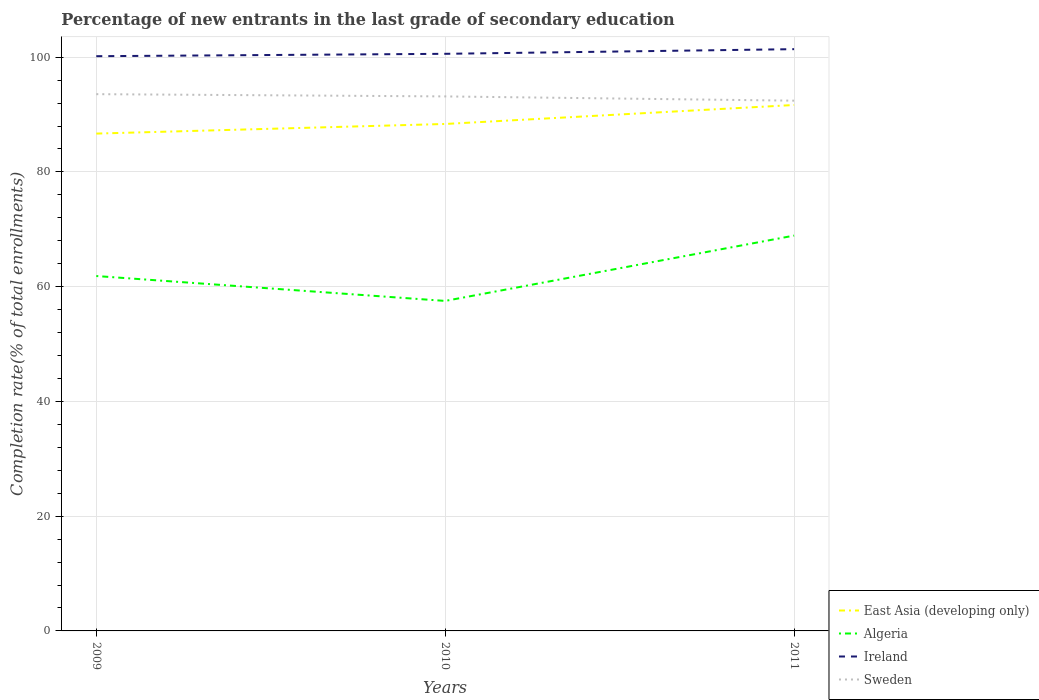How many different coloured lines are there?
Offer a very short reply. 4. Does the line corresponding to Sweden intersect with the line corresponding to Ireland?
Provide a succinct answer. No. Across all years, what is the maximum percentage of new entrants in Ireland?
Your answer should be compact. 100.17. In which year was the percentage of new entrants in Sweden maximum?
Your answer should be very brief. 2011. What is the total percentage of new entrants in Algeria in the graph?
Offer a very short reply. -7.05. What is the difference between the highest and the second highest percentage of new entrants in Sweden?
Your answer should be compact. 1.14. What is the difference between the highest and the lowest percentage of new entrants in East Asia (developing only)?
Offer a terse response. 1. Is the percentage of new entrants in Ireland strictly greater than the percentage of new entrants in Algeria over the years?
Your response must be concise. No. How many lines are there?
Your response must be concise. 4. What is the difference between two consecutive major ticks on the Y-axis?
Offer a terse response. 20. Does the graph contain any zero values?
Your answer should be compact. No. What is the title of the graph?
Your answer should be compact. Percentage of new entrants in the last grade of secondary education. What is the label or title of the Y-axis?
Provide a succinct answer. Completion rate(% of total enrollments). What is the Completion rate(% of total enrollments) in East Asia (developing only) in 2009?
Your answer should be very brief. 86.68. What is the Completion rate(% of total enrollments) in Algeria in 2009?
Provide a short and direct response. 61.86. What is the Completion rate(% of total enrollments) in Ireland in 2009?
Offer a very short reply. 100.17. What is the Completion rate(% of total enrollments) in Sweden in 2009?
Your answer should be compact. 93.56. What is the Completion rate(% of total enrollments) in East Asia (developing only) in 2010?
Ensure brevity in your answer.  88.36. What is the Completion rate(% of total enrollments) in Algeria in 2010?
Offer a terse response. 57.52. What is the Completion rate(% of total enrollments) in Ireland in 2010?
Make the answer very short. 100.59. What is the Completion rate(% of total enrollments) of Sweden in 2010?
Offer a very short reply. 93.16. What is the Completion rate(% of total enrollments) in East Asia (developing only) in 2011?
Offer a terse response. 91.67. What is the Completion rate(% of total enrollments) of Algeria in 2011?
Provide a short and direct response. 68.9. What is the Completion rate(% of total enrollments) in Ireland in 2011?
Your answer should be compact. 101.4. What is the Completion rate(% of total enrollments) of Sweden in 2011?
Provide a succinct answer. 92.42. Across all years, what is the maximum Completion rate(% of total enrollments) of East Asia (developing only)?
Ensure brevity in your answer.  91.67. Across all years, what is the maximum Completion rate(% of total enrollments) in Algeria?
Offer a terse response. 68.9. Across all years, what is the maximum Completion rate(% of total enrollments) in Ireland?
Provide a succinct answer. 101.4. Across all years, what is the maximum Completion rate(% of total enrollments) in Sweden?
Your answer should be compact. 93.56. Across all years, what is the minimum Completion rate(% of total enrollments) of East Asia (developing only)?
Ensure brevity in your answer.  86.68. Across all years, what is the minimum Completion rate(% of total enrollments) of Algeria?
Offer a terse response. 57.52. Across all years, what is the minimum Completion rate(% of total enrollments) of Ireland?
Your response must be concise. 100.17. Across all years, what is the minimum Completion rate(% of total enrollments) in Sweden?
Your answer should be compact. 92.42. What is the total Completion rate(% of total enrollments) in East Asia (developing only) in the graph?
Make the answer very short. 266.71. What is the total Completion rate(% of total enrollments) in Algeria in the graph?
Provide a short and direct response. 188.28. What is the total Completion rate(% of total enrollments) of Ireland in the graph?
Offer a terse response. 302.16. What is the total Completion rate(% of total enrollments) in Sweden in the graph?
Ensure brevity in your answer.  279.14. What is the difference between the Completion rate(% of total enrollments) in East Asia (developing only) in 2009 and that in 2010?
Keep it short and to the point. -1.68. What is the difference between the Completion rate(% of total enrollments) of Algeria in 2009 and that in 2010?
Provide a short and direct response. 4.34. What is the difference between the Completion rate(% of total enrollments) in Ireland in 2009 and that in 2010?
Make the answer very short. -0.41. What is the difference between the Completion rate(% of total enrollments) in Sweden in 2009 and that in 2010?
Provide a short and direct response. 0.39. What is the difference between the Completion rate(% of total enrollments) of East Asia (developing only) in 2009 and that in 2011?
Your answer should be compact. -4.98. What is the difference between the Completion rate(% of total enrollments) of Algeria in 2009 and that in 2011?
Your answer should be very brief. -7.05. What is the difference between the Completion rate(% of total enrollments) of Ireland in 2009 and that in 2011?
Provide a succinct answer. -1.23. What is the difference between the Completion rate(% of total enrollments) in Sweden in 2009 and that in 2011?
Offer a terse response. 1.14. What is the difference between the Completion rate(% of total enrollments) in East Asia (developing only) in 2010 and that in 2011?
Provide a succinct answer. -3.31. What is the difference between the Completion rate(% of total enrollments) in Algeria in 2010 and that in 2011?
Provide a short and direct response. -11.39. What is the difference between the Completion rate(% of total enrollments) of Ireland in 2010 and that in 2011?
Your response must be concise. -0.81. What is the difference between the Completion rate(% of total enrollments) in Sweden in 2010 and that in 2011?
Provide a short and direct response. 0.74. What is the difference between the Completion rate(% of total enrollments) in East Asia (developing only) in 2009 and the Completion rate(% of total enrollments) in Algeria in 2010?
Give a very brief answer. 29.16. What is the difference between the Completion rate(% of total enrollments) in East Asia (developing only) in 2009 and the Completion rate(% of total enrollments) in Ireland in 2010?
Give a very brief answer. -13.9. What is the difference between the Completion rate(% of total enrollments) in East Asia (developing only) in 2009 and the Completion rate(% of total enrollments) in Sweden in 2010?
Provide a succinct answer. -6.48. What is the difference between the Completion rate(% of total enrollments) in Algeria in 2009 and the Completion rate(% of total enrollments) in Ireland in 2010?
Keep it short and to the point. -38.73. What is the difference between the Completion rate(% of total enrollments) in Algeria in 2009 and the Completion rate(% of total enrollments) in Sweden in 2010?
Make the answer very short. -31.31. What is the difference between the Completion rate(% of total enrollments) in Ireland in 2009 and the Completion rate(% of total enrollments) in Sweden in 2010?
Ensure brevity in your answer.  7.01. What is the difference between the Completion rate(% of total enrollments) in East Asia (developing only) in 2009 and the Completion rate(% of total enrollments) in Algeria in 2011?
Keep it short and to the point. 17.78. What is the difference between the Completion rate(% of total enrollments) of East Asia (developing only) in 2009 and the Completion rate(% of total enrollments) of Ireland in 2011?
Provide a short and direct response. -14.72. What is the difference between the Completion rate(% of total enrollments) of East Asia (developing only) in 2009 and the Completion rate(% of total enrollments) of Sweden in 2011?
Provide a short and direct response. -5.74. What is the difference between the Completion rate(% of total enrollments) of Algeria in 2009 and the Completion rate(% of total enrollments) of Ireland in 2011?
Keep it short and to the point. -39.54. What is the difference between the Completion rate(% of total enrollments) of Algeria in 2009 and the Completion rate(% of total enrollments) of Sweden in 2011?
Your response must be concise. -30.56. What is the difference between the Completion rate(% of total enrollments) in Ireland in 2009 and the Completion rate(% of total enrollments) in Sweden in 2011?
Your answer should be compact. 7.75. What is the difference between the Completion rate(% of total enrollments) in East Asia (developing only) in 2010 and the Completion rate(% of total enrollments) in Algeria in 2011?
Your answer should be very brief. 19.46. What is the difference between the Completion rate(% of total enrollments) in East Asia (developing only) in 2010 and the Completion rate(% of total enrollments) in Ireland in 2011?
Your answer should be very brief. -13.04. What is the difference between the Completion rate(% of total enrollments) of East Asia (developing only) in 2010 and the Completion rate(% of total enrollments) of Sweden in 2011?
Offer a terse response. -4.06. What is the difference between the Completion rate(% of total enrollments) in Algeria in 2010 and the Completion rate(% of total enrollments) in Ireland in 2011?
Ensure brevity in your answer.  -43.88. What is the difference between the Completion rate(% of total enrollments) in Algeria in 2010 and the Completion rate(% of total enrollments) in Sweden in 2011?
Provide a short and direct response. -34.9. What is the difference between the Completion rate(% of total enrollments) in Ireland in 2010 and the Completion rate(% of total enrollments) in Sweden in 2011?
Make the answer very short. 8.17. What is the average Completion rate(% of total enrollments) in East Asia (developing only) per year?
Your answer should be compact. 88.9. What is the average Completion rate(% of total enrollments) in Algeria per year?
Your answer should be compact. 62.76. What is the average Completion rate(% of total enrollments) of Ireland per year?
Your answer should be compact. 100.72. What is the average Completion rate(% of total enrollments) of Sweden per year?
Give a very brief answer. 93.05. In the year 2009, what is the difference between the Completion rate(% of total enrollments) of East Asia (developing only) and Completion rate(% of total enrollments) of Algeria?
Your response must be concise. 24.83. In the year 2009, what is the difference between the Completion rate(% of total enrollments) of East Asia (developing only) and Completion rate(% of total enrollments) of Ireland?
Ensure brevity in your answer.  -13.49. In the year 2009, what is the difference between the Completion rate(% of total enrollments) of East Asia (developing only) and Completion rate(% of total enrollments) of Sweden?
Your answer should be compact. -6.87. In the year 2009, what is the difference between the Completion rate(% of total enrollments) in Algeria and Completion rate(% of total enrollments) in Ireland?
Offer a very short reply. -38.31. In the year 2009, what is the difference between the Completion rate(% of total enrollments) in Algeria and Completion rate(% of total enrollments) in Sweden?
Provide a short and direct response. -31.7. In the year 2009, what is the difference between the Completion rate(% of total enrollments) of Ireland and Completion rate(% of total enrollments) of Sweden?
Ensure brevity in your answer.  6.62. In the year 2010, what is the difference between the Completion rate(% of total enrollments) of East Asia (developing only) and Completion rate(% of total enrollments) of Algeria?
Your answer should be very brief. 30.84. In the year 2010, what is the difference between the Completion rate(% of total enrollments) of East Asia (developing only) and Completion rate(% of total enrollments) of Ireland?
Ensure brevity in your answer.  -12.23. In the year 2010, what is the difference between the Completion rate(% of total enrollments) of East Asia (developing only) and Completion rate(% of total enrollments) of Sweden?
Keep it short and to the point. -4.8. In the year 2010, what is the difference between the Completion rate(% of total enrollments) in Algeria and Completion rate(% of total enrollments) in Ireland?
Give a very brief answer. -43.07. In the year 2010, what is the difference between the Completion rate(% of total enrollments) of Algeria and Completion rate(% of total enrollments) of Sweden?
Offer a terse response. -35.64. In the year 2010, what is the difference between the Completion rate(% of total enrollments) in Ireland and Completion rate(% of total enrollments) in Sweden?
Offer a terse response. 7.42. In the year 2011, what is the difference between the Completion rate(% of total enrollments) of East Asia (developing only) and Completion rate(% of total enrollments) of Algeria?
Ensure brevity in your answer.  22.76. In the year 2011, what is the difference between the Completion rate(% of total enrollments) in East Asia (developing only) and Completion rate(% of total enrollments) in Ireland?
Make the answer very short. -9.73. In the year 2011, what is the difference between the Completion rate(% of total enrollments) of East Asia (developing only) and Completion rate(% of total enrollments) of Sweden?
Offer a terse response. -0.75. In the year 2011, what is the difference between the Completion rate(% of total enrollments) of Algeria and Completion rate(% of total enrollments) of Ireland?
Offer a terse response. -32.49. In the year 2011, what is the difference between the Completion rate(% of total enrollments) of Algeria and Completion rate(% of total enrollments) of Sweden?
Your answer should be very brief. -23.52. In the year 2011, what is the difference between the Completion rate(% of total enrollments) in Ireland and Completion rate(% of total enrollments) in Sweden?
Provide a succinct answer. 8.98. What is the ratio of the Completion rate(% of total enrollments) in Algeria in 2009 to that in 2010?
Your answer should be very brief. 1.08. What is the ratio of the Completion rate(% of total enrollments) in Sweden in 2009 to that in 2010?
Offer a very short reply. 1. What is the ratio of the Completion rate(% of total enrollments) of East Asia (developing only) in 2009 to that in 2011?
Provide a succinct answer. 0.95. What is the ratio of the Completion rate(% of total enrollments) of Algeria in 2009 to that in 2011?
Offer a very short reply. 0.9. What is the ratio of the Completion rate(% of total enrollments) in Ireland in 2009 to that in 2011?
Your answer should be compact. 0.99. What is the ratio of the Completion rate(% of total enrollments) of Sweden in 2009 to that in 2011?
Your answer should be compact. 1.01. What is the ratio of the Completion rate(% of total enrollments) of East Asia (developing only) in 2010 to that in 2011?
Provide a short and direct response. 0.96. What is the ratio of the Completion rate(% of total enrollments) in Algeria in 2010 to that in 2011?
Ensure brevity in your answer.  0.83. What is the ratio of the Completion rate(% of total enrollments) in Ireland in 2010 to that in 2011?
Keep it short and to the point. 0.99. What is the difference between the highest and the second highest Completion rate(% of total enrollments) in East Asia (developing only)?
Ensure brevity in your answer.  3.31. What is the difference between the highest and the second highest Completion rate(% of total enrollments) in Algeria?
Provide a succinct answer. 7.05. What is the difference between the highest and the second highest Completion rate(% of total enrollments) in Ireland?
Your response must be concise. 0.81. What is the difference between the highest and the second highest Completion rate(% of total enrollments) in Sweden?
Your response must be concise. 0.39. What is the difference between the highest and the lowest Completion rate(% of total enrollments) in East Asia (developing only)?
Your answer should be very brief. 4.98. What is the difference between the highest and the lowest Completion rate(% of total enrollments) of Algeria?
Your answer should be very brief. 11.39. What is the difference between the highest and the lowest Completion rate(% of total enrollments) of Ireland?
Provide a succinct answer. 1.23. What is the difference between the highest and the lowest Completion rate(% of total enrollments) in Sweden?
Provide a short and direct response. 1.14. 